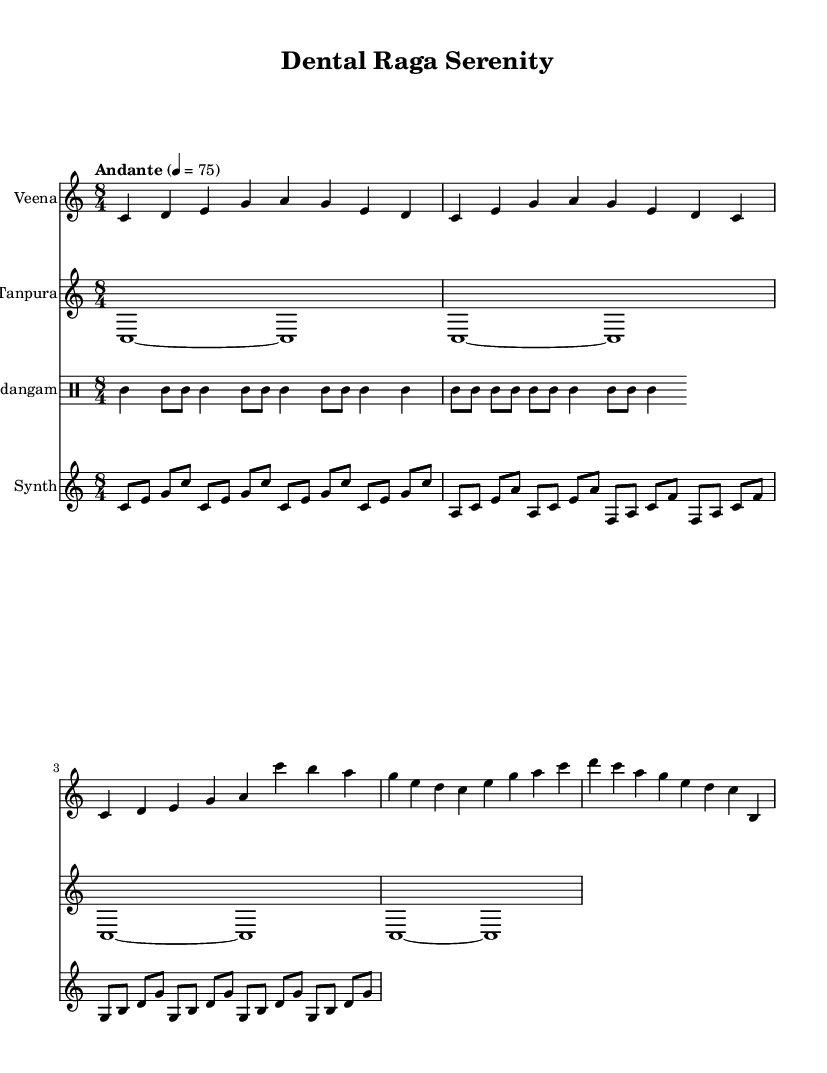What is the key signature of this music? The key signature indicated in the music is C major, which means there are no sharps or flats to account for. This is determined by looking for the absence of accidentals at the beginning of the staff.
Answer: C major What is the time signature of the piece? The time signature, found at the beginning of the score, is 8/4. This indicates that there are eight beats per measure with each quarter note receiving one beat.
Answer: 8/4 What is the tempo marking for this piece? The tempo marking, located at the beginning of the score, states "Andante," which is a tempo indication that generally means a moderately slow pace, typically around 76-108 beats per minute.
Answer: Andante What instruments are included in this score? The score features four distinct instruments: Veena, Tanpura, Mridangam, and Synth. These can be identified by their respective staff labels at the beginning of each line in the score.
Answer: Veena, Tanpura, Mridangam, Synth How many measures are there in the Veena part? The Veena part, when counted, contains six measures before it repeats or concludes. Measures can typically be counted by the number of vertical lines in the staff, each indicating a new measure.
Answer: Six What is the rhythmic pattern of the Mridangam part? The Mridangam part presents a repetitive rhythmic pattern, characterized by the "tomml" sounds that create a steady beat throughout. Examining the notation reveals these rhythmic motifs which create the foundation of the piece.
Answer: Repetitive "tomml" pattern Which section contains the highest pitch in the piece? The highest pitch in the score is found in the synth part where the notes go up to A and B, as found in the upper register of the staff where they are notated. This can be observed by analyzing the relative heights of the notes on the staff.
Answer: Synth part 